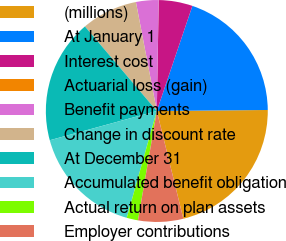<chart> <loc_0><loc_0><loc_500><loc_500><pie_chart><fcel>(millions)<fcel>At January 1<fcel>Interest cost<fcel>Actuarial loss (gain)<fcel>Benefit payments<fcel>Change in discount rate<fcel>At December 31<fcel>Accumulated benefit obligation<fcel>Actual return on plan assets<fcel>Employer contributions<nl><fcel>21.3%<fcel>19.66%<fcel>4.92%<fcel>0.01%<fcel>3.28%<fcel>8.2%<fcel>18.03%<fcel>16.39%<fcel>1.65%<fcel>6.56%<nl></chart> 